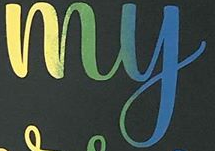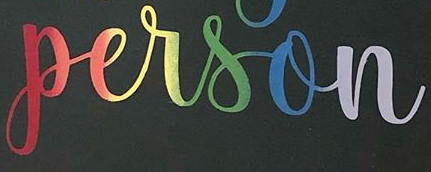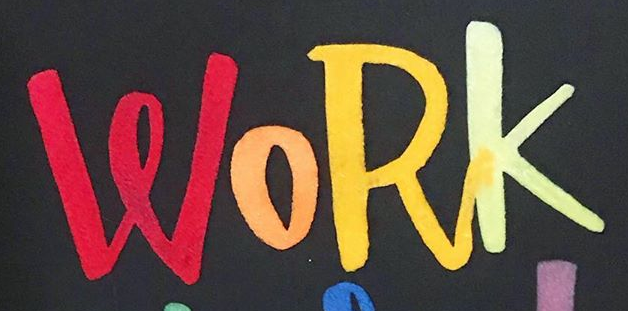What words are shown in these images in order, separated by a semicolon? my; person; WORK 